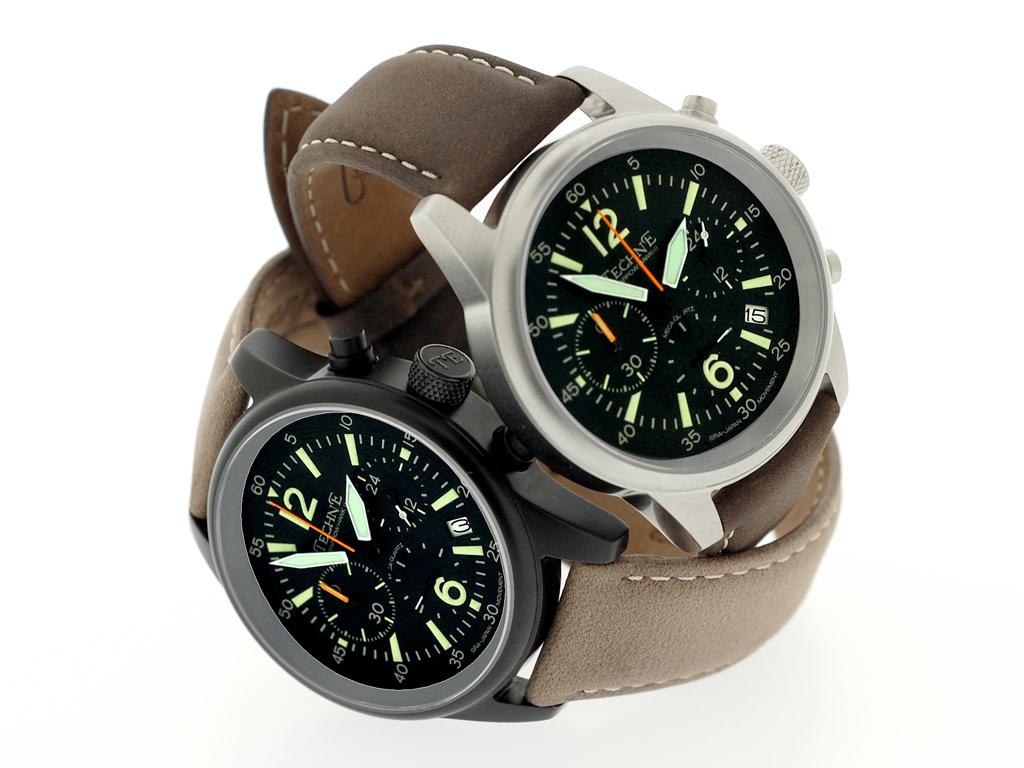What is the brand of watch?
Keep it short and to the point. Techne. What time does the watch on the right show?
Ensure brevity in your answer.  1:54. 